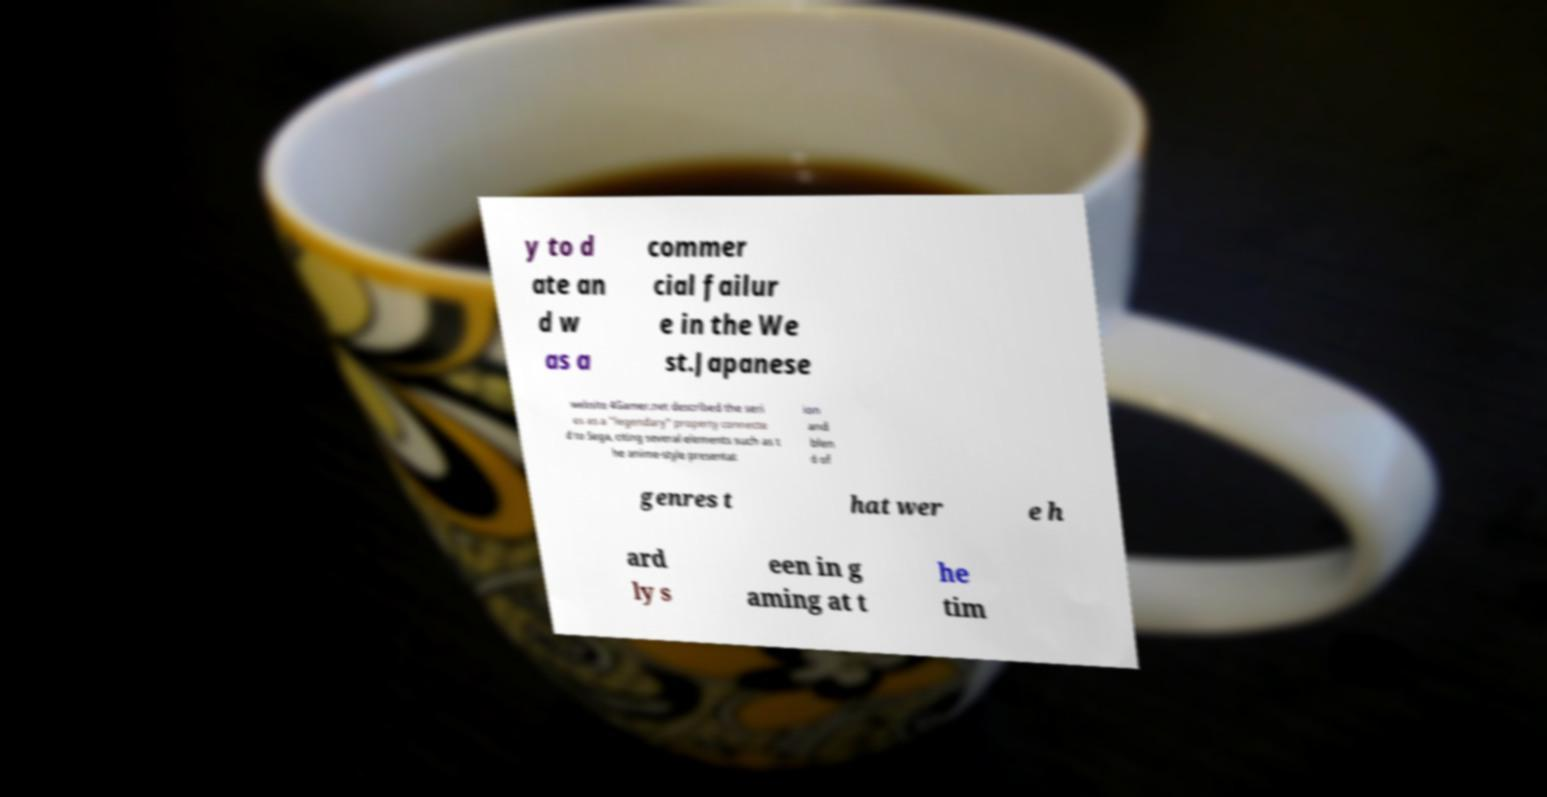What messages or text are displayed in this image? I need them in a readable, typed format. y to d ate an d w as a commer cial failur e in the We st.Japanese website 4Gamer.net described the seri es as a "legendary" property connecte d to Sega, citing several elements such as t he anime-style presentat ion and blen d of genres t hat wer e h ard ly s een in g aming at t he tim 